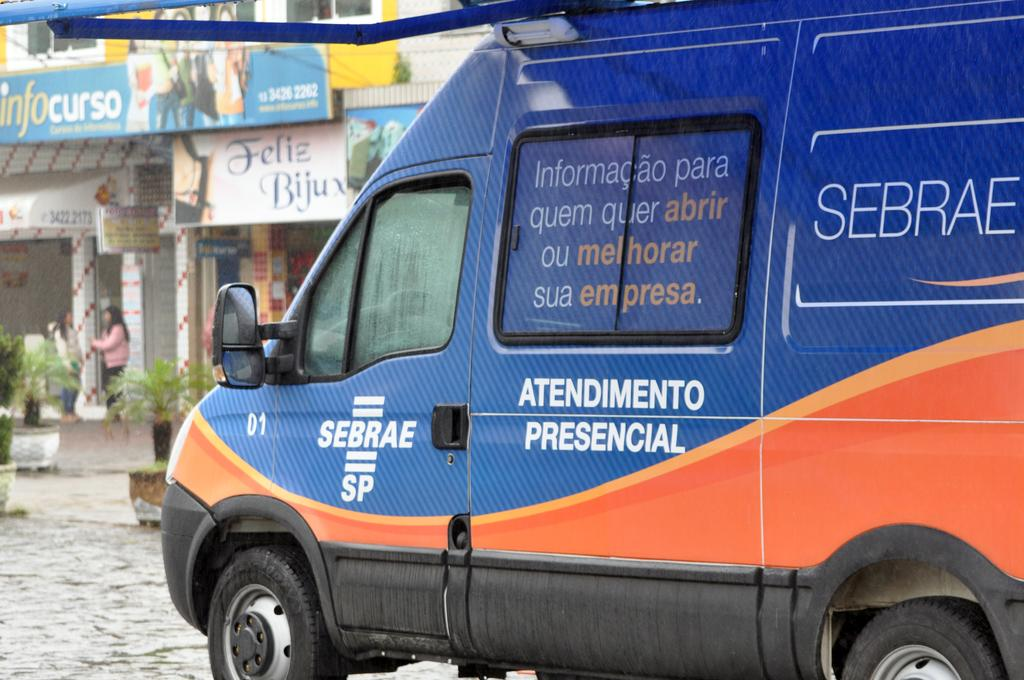Provide a one-sentence caption for the provided image. Blue sebrae van riding on a road with buildings. 